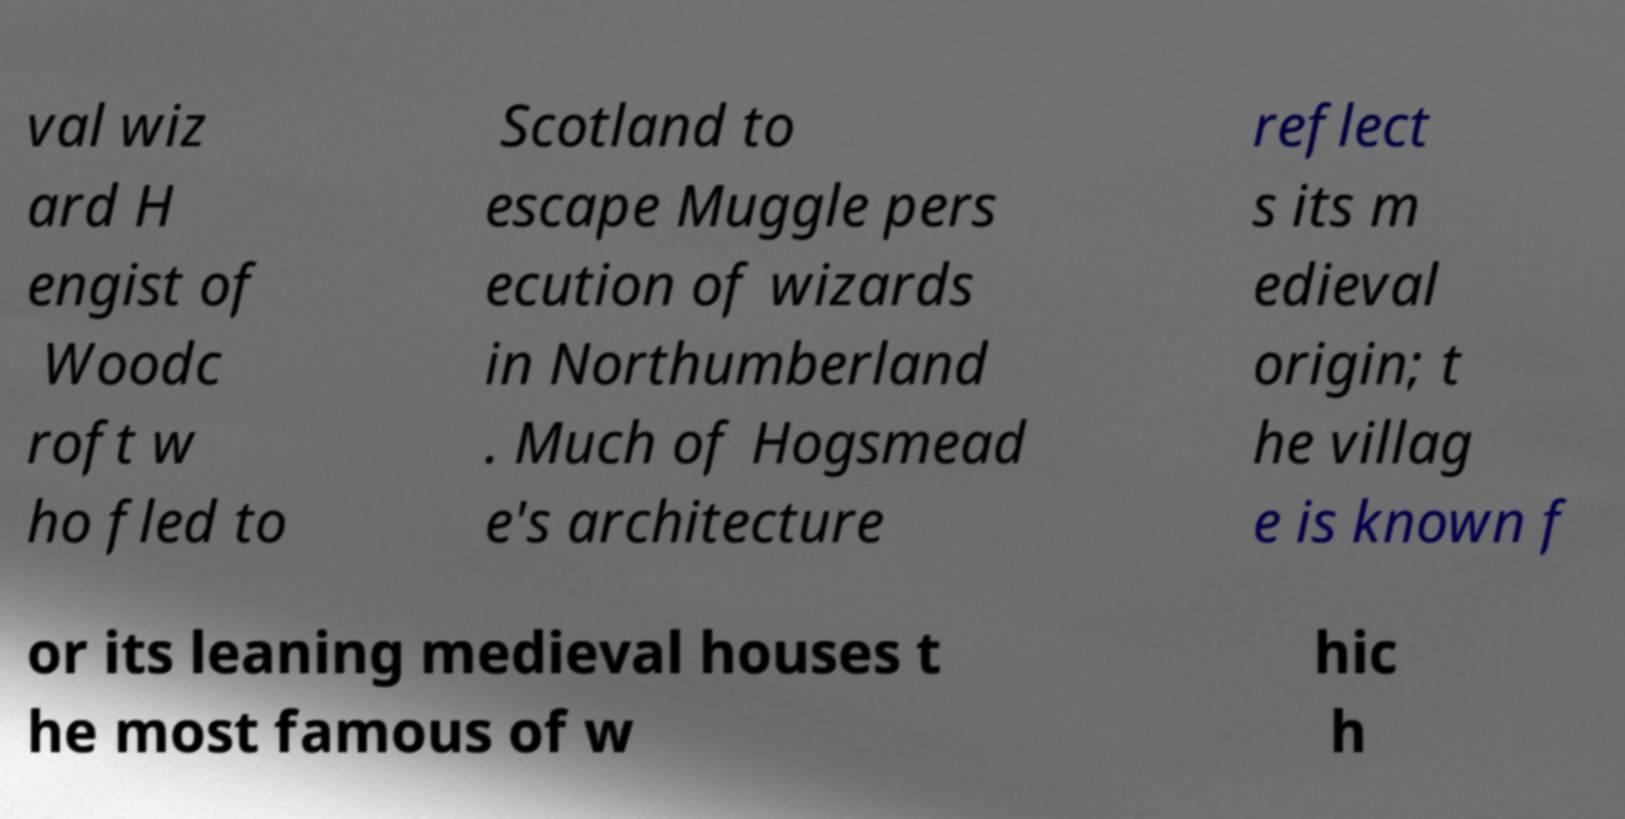Can you accurately transcribe the text from the provided image for me? val wiz ard H engist of Woodc roft w ho fled to Scotland to escape Muggle pers ecution of wizards in Northumberland . Much of Hogsmead e's architecture reflect s its m edieval origin; t he villag e is known f or its leaning medieval houses t he most famous of w hic h 